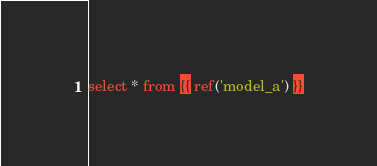<code> <loc_0><loc_0><loc_500><loc_500><_SQL_>
select * from {{ ref('model_a') }}
</code> 